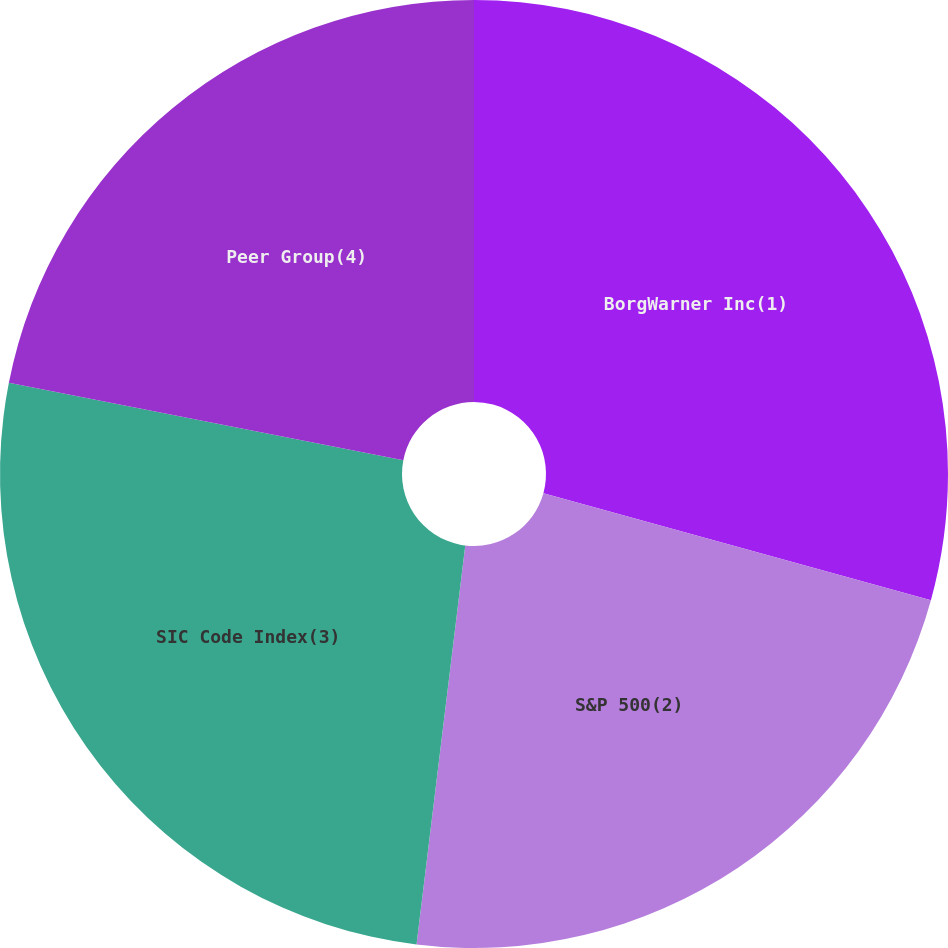Convert chart to OTSL. <chart><loc_0><loc_0><loc_500><loc_500><pie_chart><fcel>BorgWarner Inc(1)<fcel>S&P 500(2)<fcel>SIC Code Index(3)<fcel>Peer Group(4)<nl><fcel>29.29%<fcel>22.65%<fcel>26.15%<fcel>21.92%<nl></chart> 